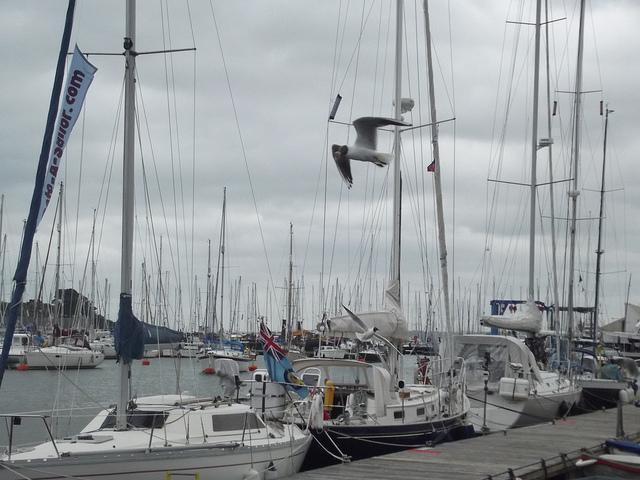What baby name is related to this place?
Select the correct answer and articulate reasoning with the following format: 'Answer: answer
Rationale: rationale.'
Options: Dell, shemp, apple, marina. Answer: marina.
Rationale: Marina is related. 